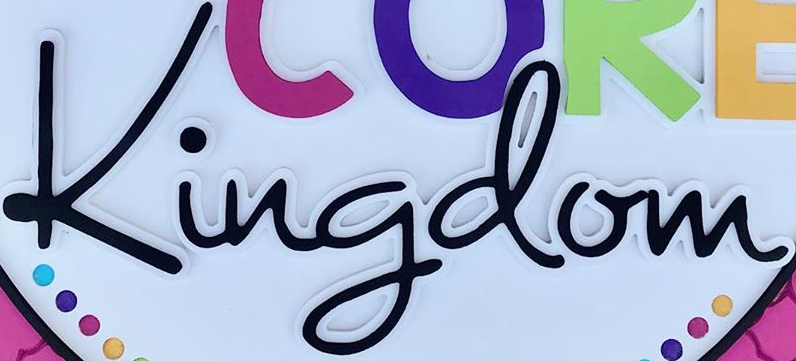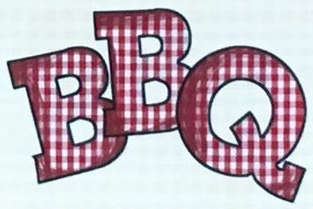Transcribe the words shown in these images in order, separated by a semicolon. Kingdom; BBQ 